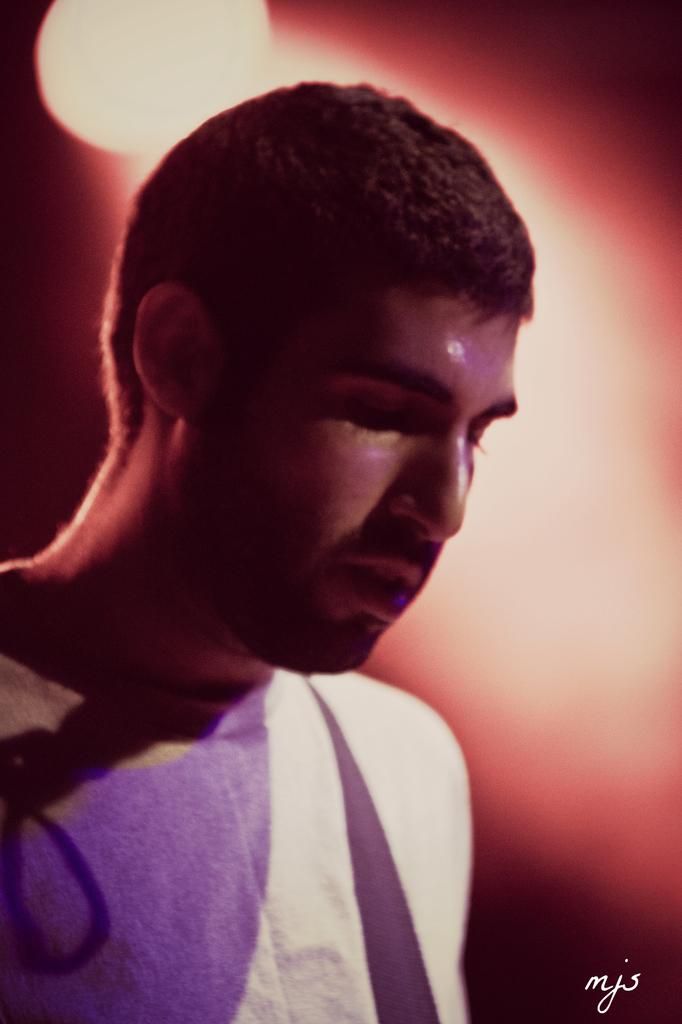What is the main subject of the image? There is a person in the image. What is the person wearing? The person is wearing a violet and white t-shirt and a brown t-shirt. Can you describe the lighting in the image? There is an orange-colored light in the background of the image. How many goldfish are swimming in the person's t-shirt in the image? There are no goldfish present in the image, and they are not swimming in the person's t-shirt. Is the person's partner visible in the image? The provided facts do not mention a partner, so we cannot determine if the person's partner is visible in the image. --- Facts: 1. There is a car in the image. 2. The car is red. 3. The car has four wheels. 4. There is a road in the image. 5. The road is paved. Absurd Topics: bird, ocean, mountain Conversation: What is the main subject of the image? There is a car in the image. Can you describe the car's appearance? The car is red and has four wheels. What is the setting of the image? There is a road in the image, and the road is paved. Reasoning: Let's think step by step in order to produce the conversation. We start by identifying the main subject of the image, which is the car. Then, we describe the car's appearance, focusing on its color and the number of wheels. Finally, we mention the setting of the image, noting the presence of a road and its paved surface. Absurd Question/Answer: Can you see any birds flying over the ocean in the image? There is no ocean or birds visible in the image; it features a red car on a paved road. Is there a mountain visible in the background of the image? The provided facts do not mention a mountain, so we cannot determine if a mountain is visible in the background. 